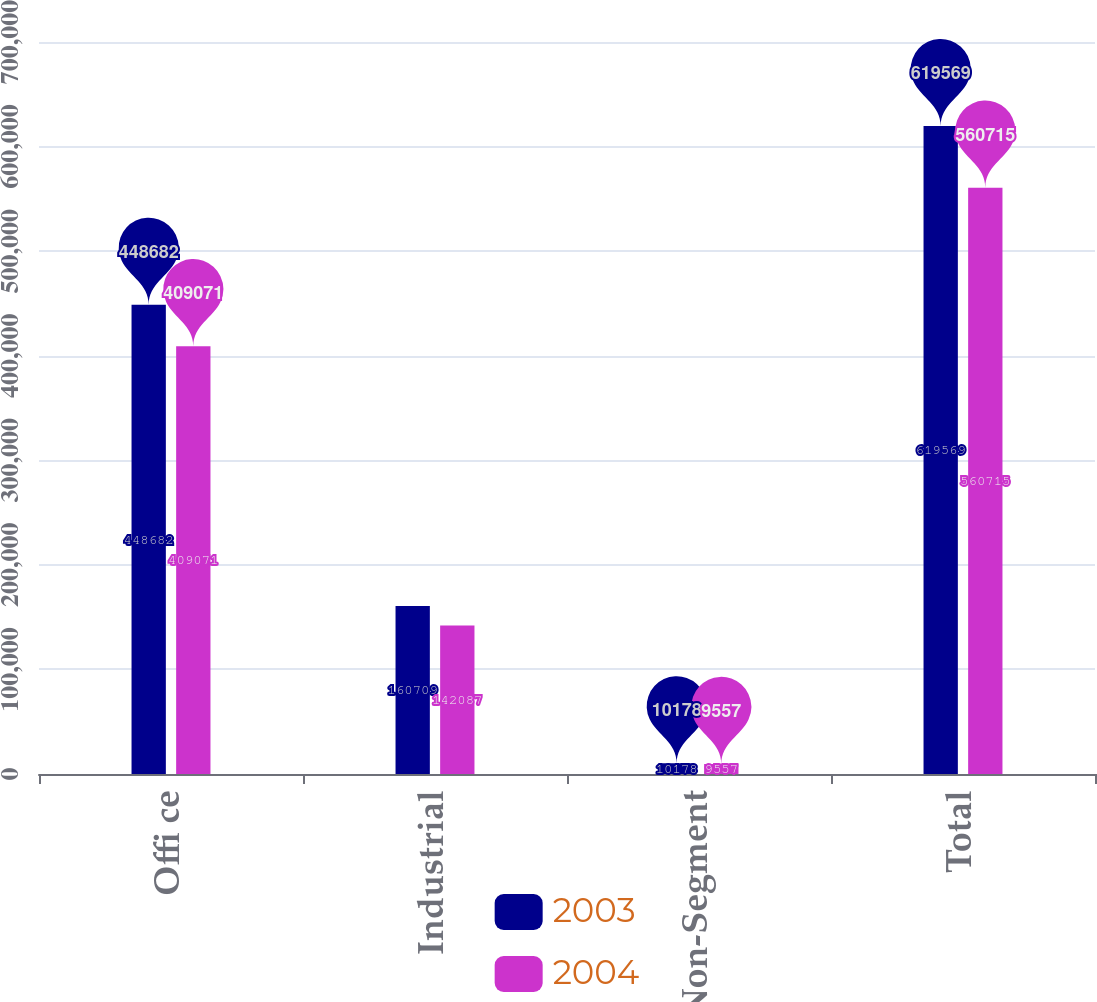Convert chart. <chart><loc_0><loc_0><loc_500><loc_500><stacked_bar_chart><ecel><fcel>Offi ce<fcel>Industrial<fcel>Non-Segment<fcel>Total<nl><fcel>2003<fcel>448682<fcel>160709<fcel>10178<fcel>619569<nl><fcel>2004<fcel>409071<fcel>142087<fcel>9557<fcel>560715<nl></chart> 